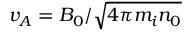Convert formula to latex. <formula><loc_0><loc_0><loc_500><loc_500>v _ { A } = B _ { 0 } / \sqrt { 4 \pi m _ { i } n _ { 0 } }</formula> 